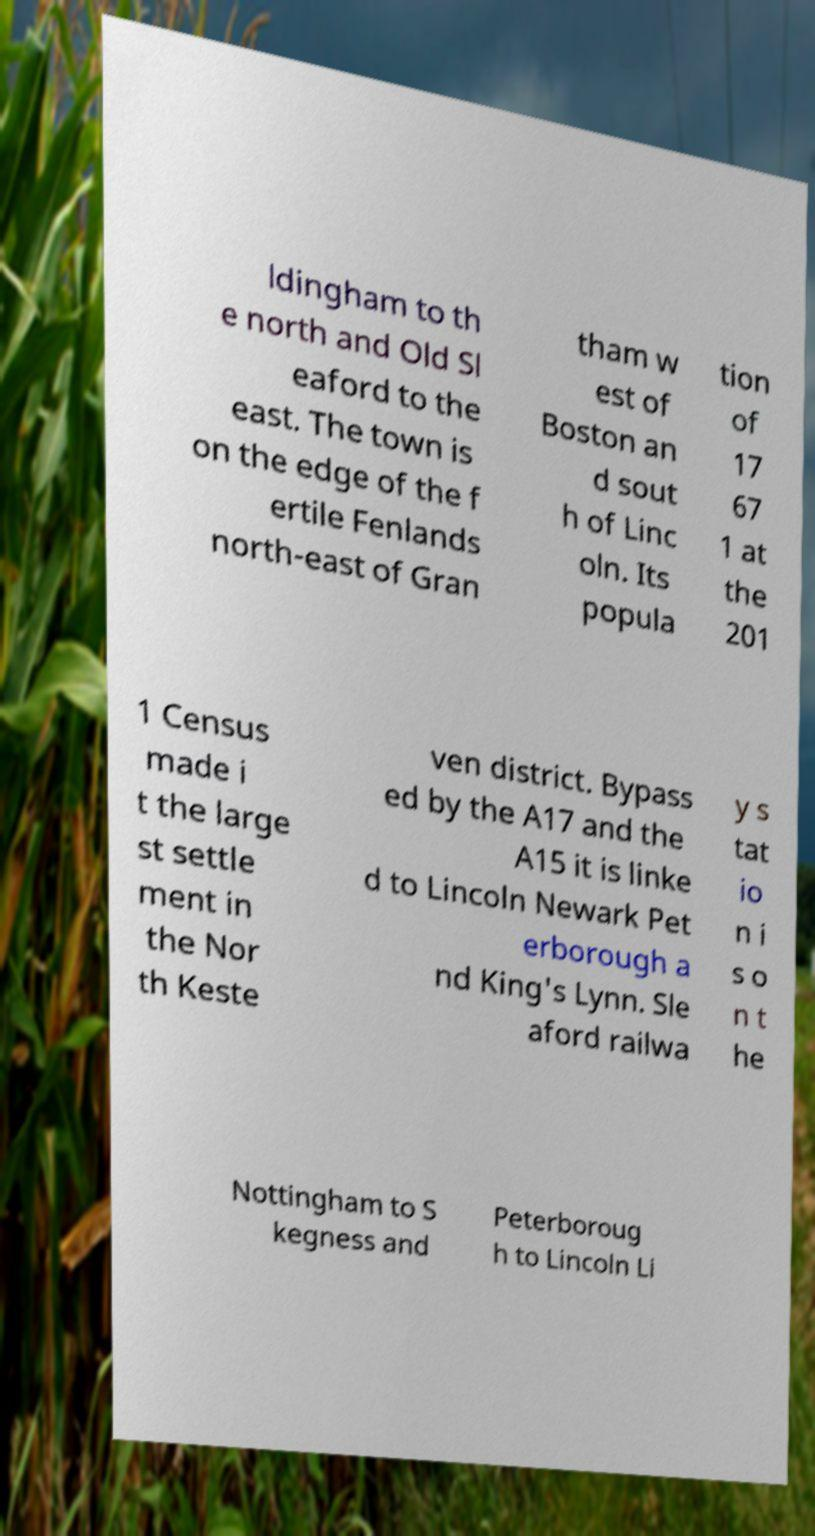Could you extract and type out the text from this image? ldingham to th e north and Old Sl eaford to the east. The town is on the edge of the f ertile Fenlands north-east of Gran tham w est of Boston an d sout h of Linc oln. Its popula tion of 17 67 1 at the 201 1 Census made i t the large st settle ment in the Nor th Keste ven district. Bypass ed by the A17 and the A15 it is linke d to Lincoln Newark Pet erborough a nd King's Lynn. Sle aford railwa y s tat io n i s o n t he Nottingham to S kegness and Peterboroug h to Lincoln Li 